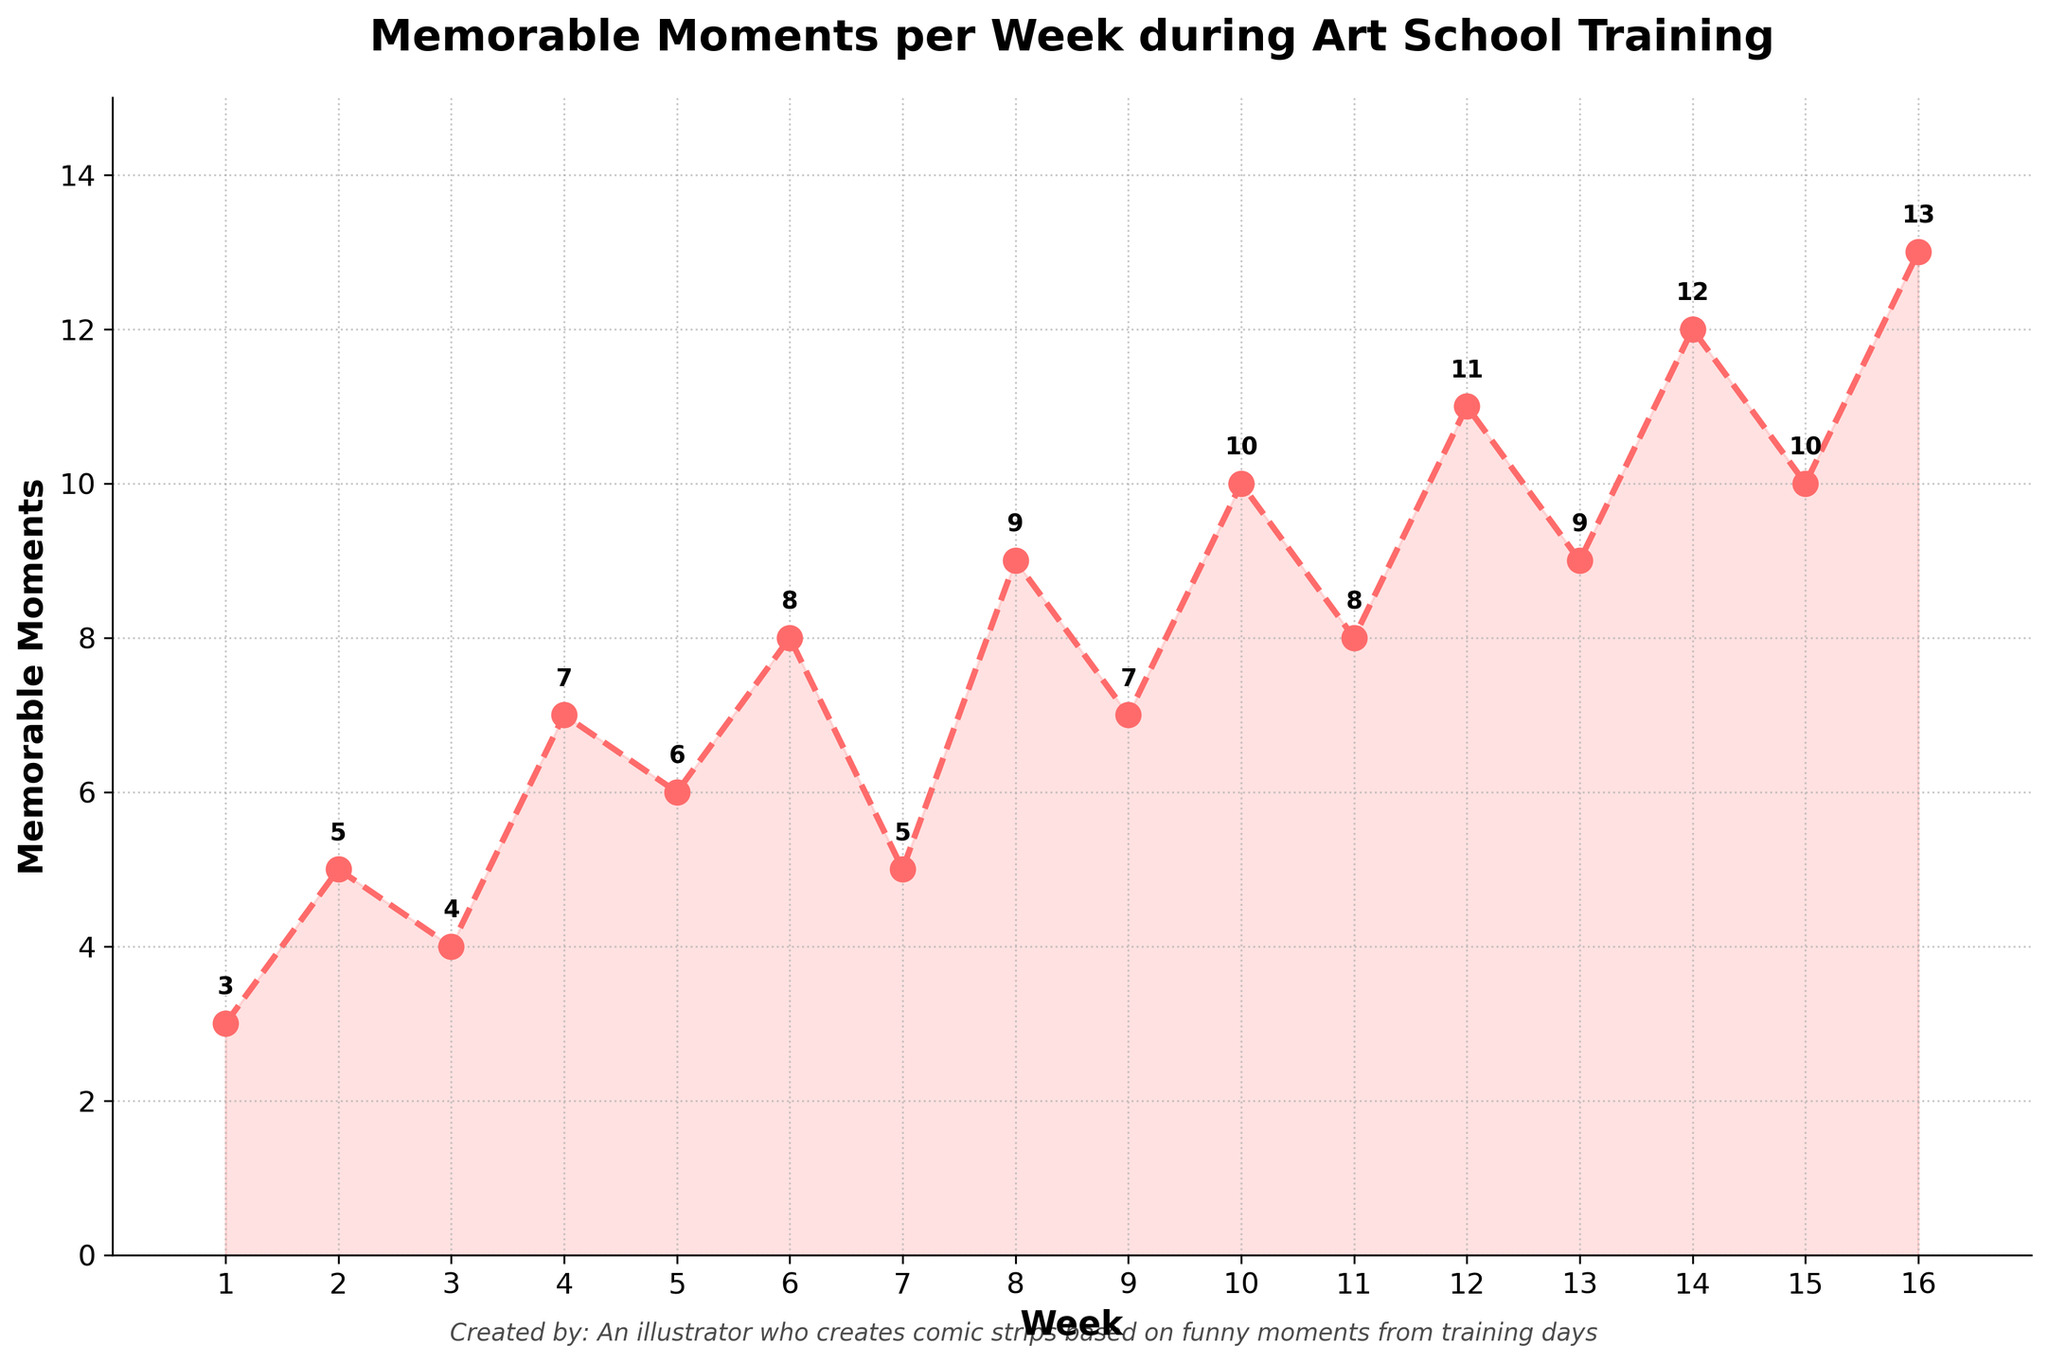How does the number of memorable moments in Week 1 compare to Week 5? Week 1 has 3 memorable moments and Week 5 has 6 memorable moments. To compare, note that Week 5 has 3 more memorable moments than Week 1.
Answer: Week 5 has 3 more moments During which week does the number of memorable moments first reach double digits? Double digits mean 10 or more. Looking at the chart, we see that Week 10 has 10 memorable moments, and it is the first week to reach double digits.
Answer: Week 10 What is the average number of memorable moments from Week 1 to Week 16? To find the average, add all the numbers of memorable moments and divide by the number of weeks. Sum = 3 + 5 + 4 + 7 + 6 + 8 + 5 + 9 + 7 + 10 + 8 + 11 + 9 + 12 + 10 + 13 = 127. Average = 127 / 16 = 7.9375
Answer: 7.9375 What is the total number of memorable moments recorded in the first half (Week 1-8) compared to the second half (Week 9-16)? First half: 3 + 5 + 4 + 7 + 6 + 8 + 5 + 9 = 47. Second half: 7 + 10 + 8 + 11 + 9 + 12 + 10 + 13 = 80. Total difference = 80 - 47 = 33
Answer: 33 Describe the trend of memorable moments from Week 1 to Week 16? The trend shows a general increase in memorable moments over the weeks. Starting from 3 moments in Week 1, there is a visible rise with some fluctuations, reaching 13 moments in Week 16.
Answer: Increasing trend Which week has the highest number of memorable moments and how many? By looking at the chart for the highest value, Week 16 has the highest number of memorable moments, which is 13.
Answer: Week 16, 13 moments What is the maximum difference in the number of memorable moments observed between any two consecutive weeks? Calculate the differences between each pair of consecutive weeks: (5-3)=2, (4-5)=-1, (7-4)=3, (6-7)=-1, (8-6)=2, (5-8)=-3, (9-5)=4, (7-9)=-2, (10-7)=3, (8-10)=-2, (11-8)=3, (9-11)=-2, (12-9)=3, (10-12)=-2, (13-10)=3. The maximum difference is 4 between Week 7 and Week 8.
Answer: 4 How many weeks have more than 8 memorable moments? Count the weeks with more than 8 memorable moments: Week 8 (9), Week 10 (10), Week 12 (11), Week 14 (12), Week 15 (10), Week 16 (13). There are 6 weeks in total.
Answer: 6 